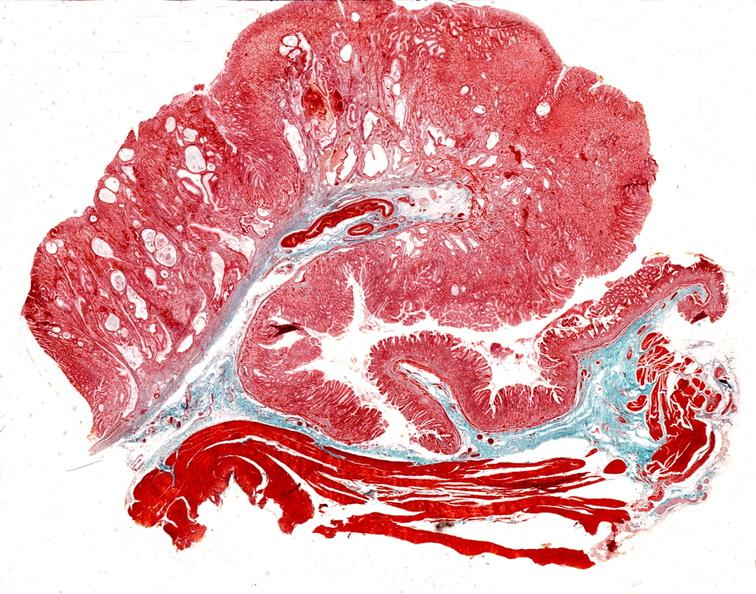s gastrointestinal present?
Answer the question using a single word or phrase. Yes 